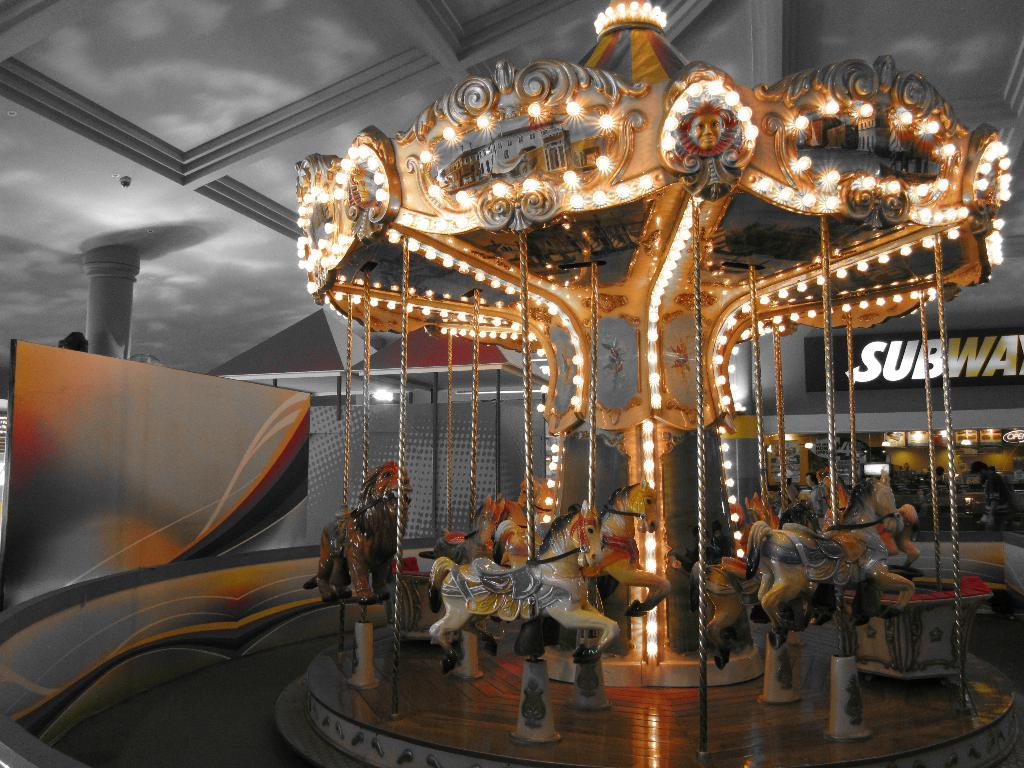What is the main subject of the image? There is a merry-go-round in the image. What can be seen in addition to the merry-go-round? There are lights visible in the image. Is there any text present in the image? Yes, there is a word written in the image. What is the surface on which the merry-go-round is placed? There is a platform in the image. How would you describe the lighting conditions in the image? The background of the image is a bit dark. What is the income of the squirrel in the image? There is no squirrel present in the image, so it is not possible to determine its income. 